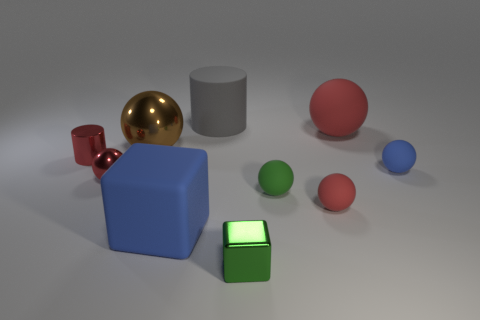How many red spheres must be subtracted to get 1 red spheres? 2 Subtract all small blue spheres. How many spheres are left? 5 Subtract all spheres. How many objects are left? 4 Subtract all red spheres. How many spheres are left? 3 Subtract 1 blocks. How many blocks are left? 1 Subtract 1 blue spheres. How many objects are left? 9 Subtract all cyan cylinders. Subtract all blue spheres. How many cylinders are left? 2 Subtract all brown cylinders. How many gray balls are left? 0 Subtract all green shiny blocks. Subtract all tiny metal things. How many objects are left? 6 Add 1 gray matte cylinders. How many gray matte cylinders are left? 2 